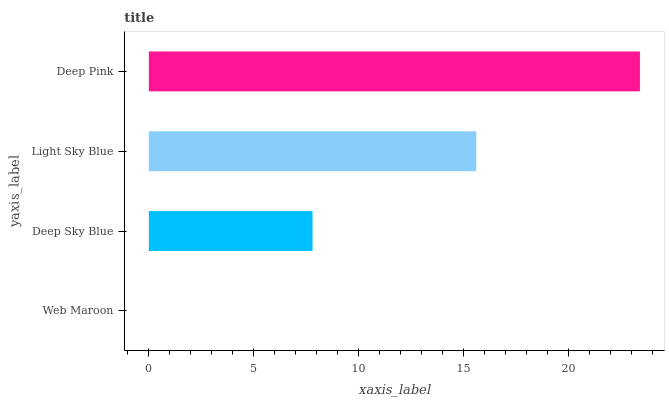Is Web Maroon the minimum?
Answer yes or no. Yes. Is Deep Pink the maximum?
Answer yes or no. Yes. Is Deep Sky Blue the minimum?
Answer yes or no. No. Is Deep Sky Blue the maximum?
Answer yes or no. No. Is Deep Sky Blue greater than Web Maroon?
Answer yes or no. Yes. Is Web Maroon less than Deep Sky Blue?
Answer yes or no. Yes. Is Web Maroon greater than Deep Sky Blue?
Answer yes or no. No. Is Deep Sky Blue less than Web Maroon?
Answer yes or no. No. Is Light Sky Blue the high median?
Answer yes or no. Yes. Is Deep Sky Blue the low median?
Answer yes or no. Yes. Is Web Maroon the high median?
Answer yes or no. No. Is Light Sky Blue the low median?
Answer yes or no. No. 